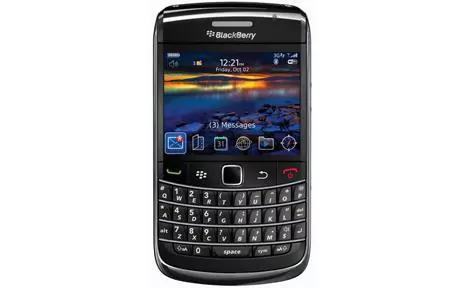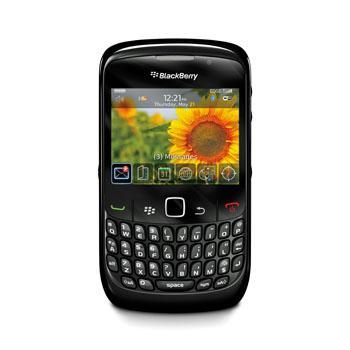The first image is the image on the left, the second image is the image on the right. Considering the images on both sides, is "There are a number of stars to the bottom right of one of the phones." valid? Answer yes or no. No. The first image is the image on the left, the second image is the image on the right. Considering the images on both sides, is "Both phones display the same time." valid? Answer yes or no. Yes. 